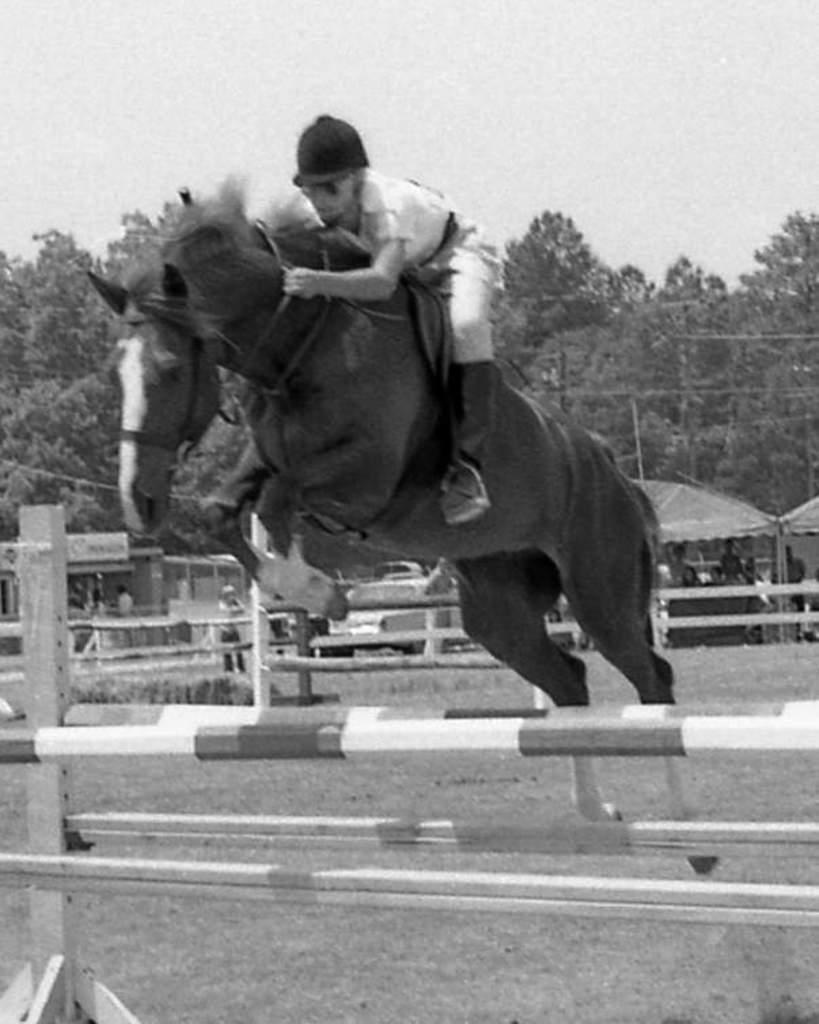Could you give a brief overview of what you see in this image? In this image in the center there is one horse on the horse there is one person who is sitting and riding, and on the background there are some trees and in the foreground there are some wooden sticks are there. And on the background there are some tents and some people are there. 